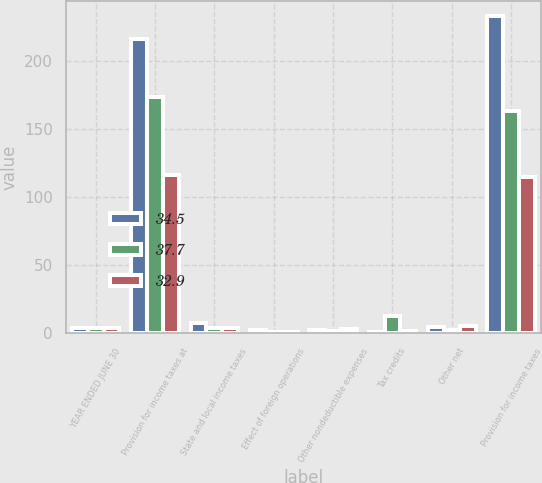<chart> <loc_0><loc_0><loc_500><loc_500><stacked_bar_chart><ecel><fcel>YEAR ENDED JUNE 30<fcel>Provision for income taxes at<fcel>State and local income taxes<fcel>Effect of foreign operations<fcel>Other nondeductible expenses<fcel>Tax credits<fcel>Other net<fcel>Provision for income taxes<nl><fcel>34.5<fcel>4<fcel>215.9<fcel>7.6<fcel>2.8<fcel>2.7<fcel>1.3<fcel>4.4<fcel>232.6<nl><fcel>37.7<fcel>4<fcel>173.4<fcel>3.9<fcel>1<fcel>1.7<fcel>12.5<fcel>2.2<fcel>163.3<nl><fcel>32.9<fcel>4<fcel>116.3<fcel>4<fcel>0.9<fcel>3.2<fcel>2.1<fcel>5.8<fcel>114.7<nl></chart> 